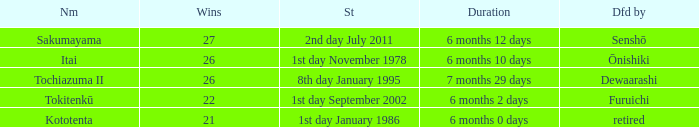Which Start has a Duration of 6 months 2 days? 1st day September 2002. 